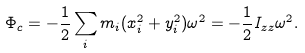<formula> <loc_0><loc_0><loc_500><loc_500>\Phi _ { c } = - \frac { 1 } { 2 } \sum _ { i } m _ { i } ( x _ { i } ^ { 2 } + y _ { i } ^ { 2 } ) \omega ^ { 2 } = - \frac { 1 } { 2 } I _ { z z } \omega ^ { 2 } .</formula> 